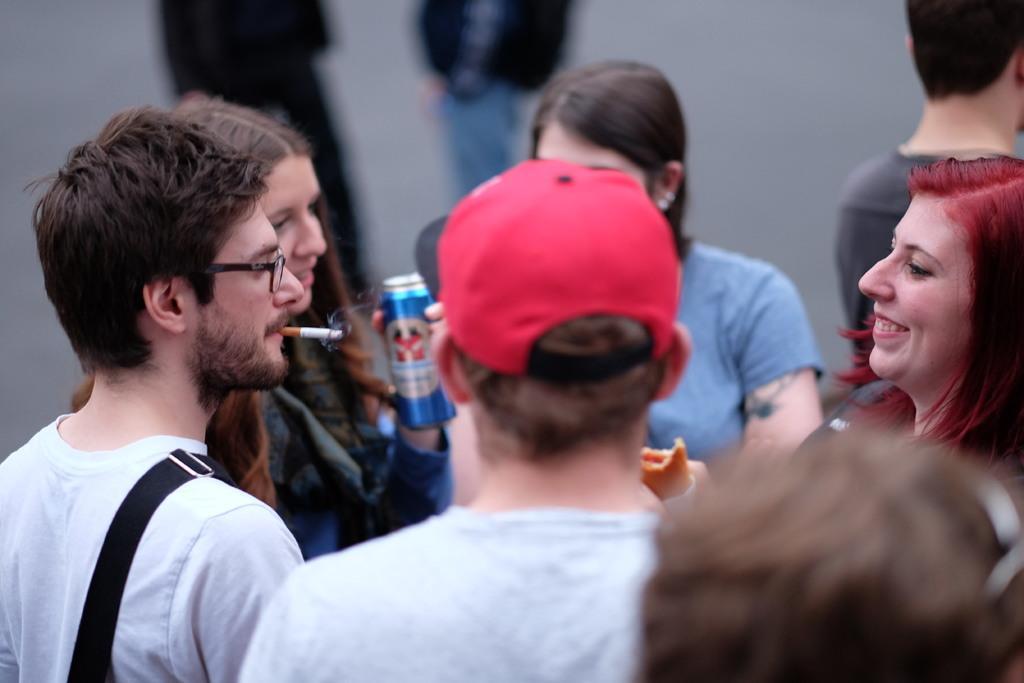Please provide a concise description of this image. In this picture I can see few people who are standing in front and I see that the man on the left is having a cigar in his mouth and the woman on the right is smiling and another woman on the left is holding a can. I see that that it is blurred in the background. 